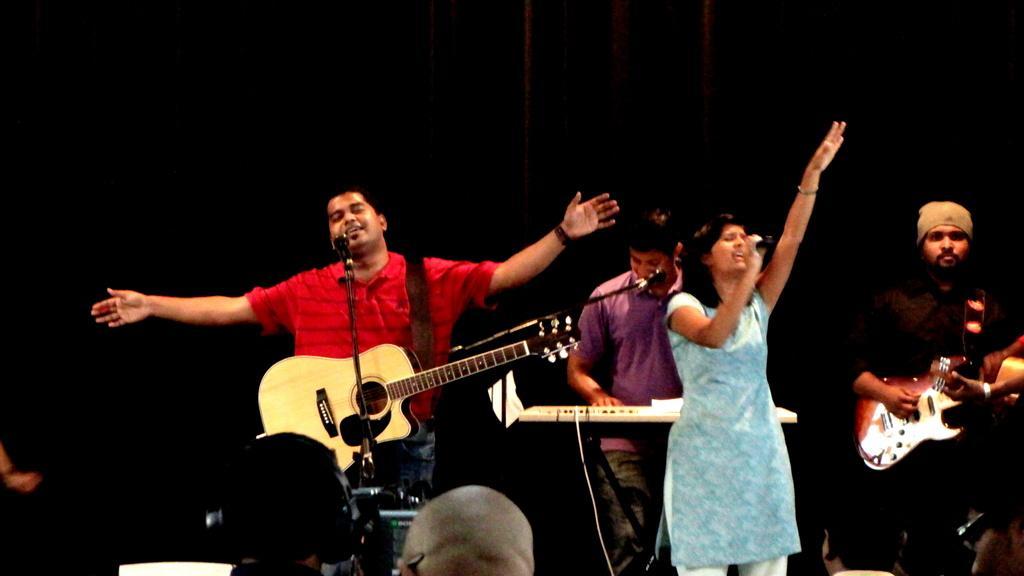Can you describe this image briefly? In this picture, we see people performing and playing the musical instruments. with the help of a microphone. 